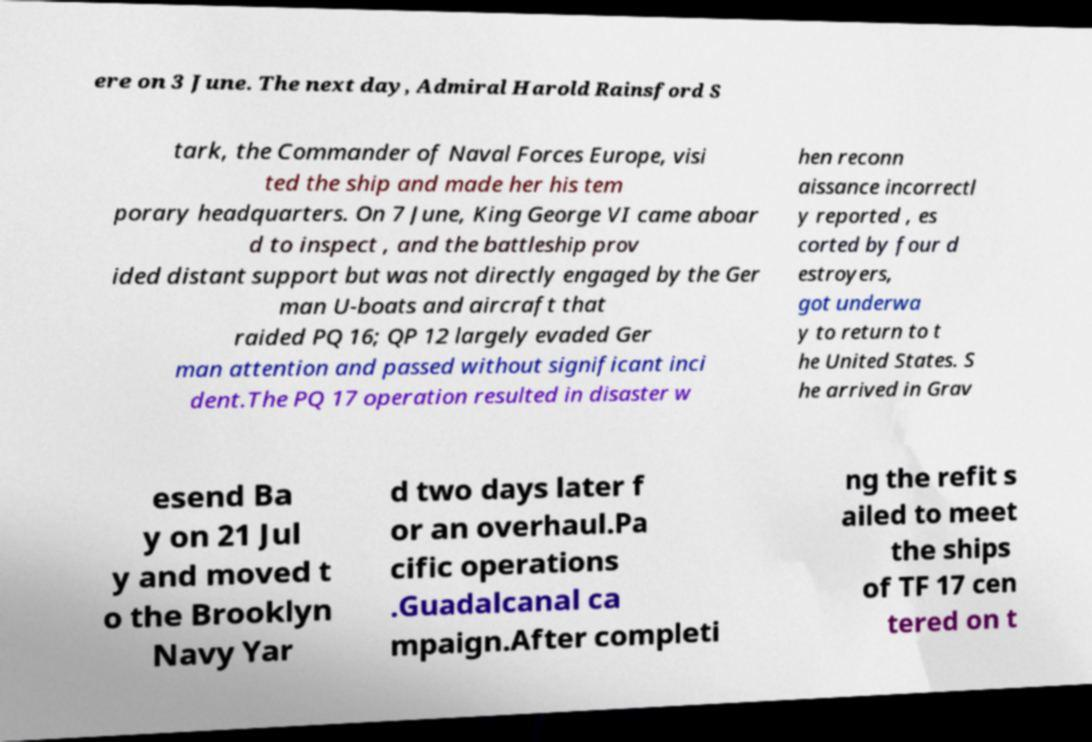Can you accurately transcribe the text from the provided image for me? ere on 3 June. The next day, Admiral Harold Rainsford S tark, the Commander of Naval Forces Europe, visi ted the ship and made her his tem porary headquarters. On 7 June, King George VI came aboar d to inspect , and the battleship prov ided distant support but was not directly engaged by the Ger man U-boats and aircraft that raided PQ 16; QP 12 largely evaded Ger man attention and passed without significant inci dent.The PQ 17 operation resulted in disaster w hen reconn aissance incorrectl y reported , es corted by four d estroyers, got underwa y to return to t he United States. S he arrived in Grav esend Ba y on 21 Jul y and moved t o the Brooklyn Navy Yar d two days later f or an overhaul.Pa cific operations .Guadalcanal ca mpaign.After completi ng the refit s ailed to meet the ships of TF 17 cen tered on t 